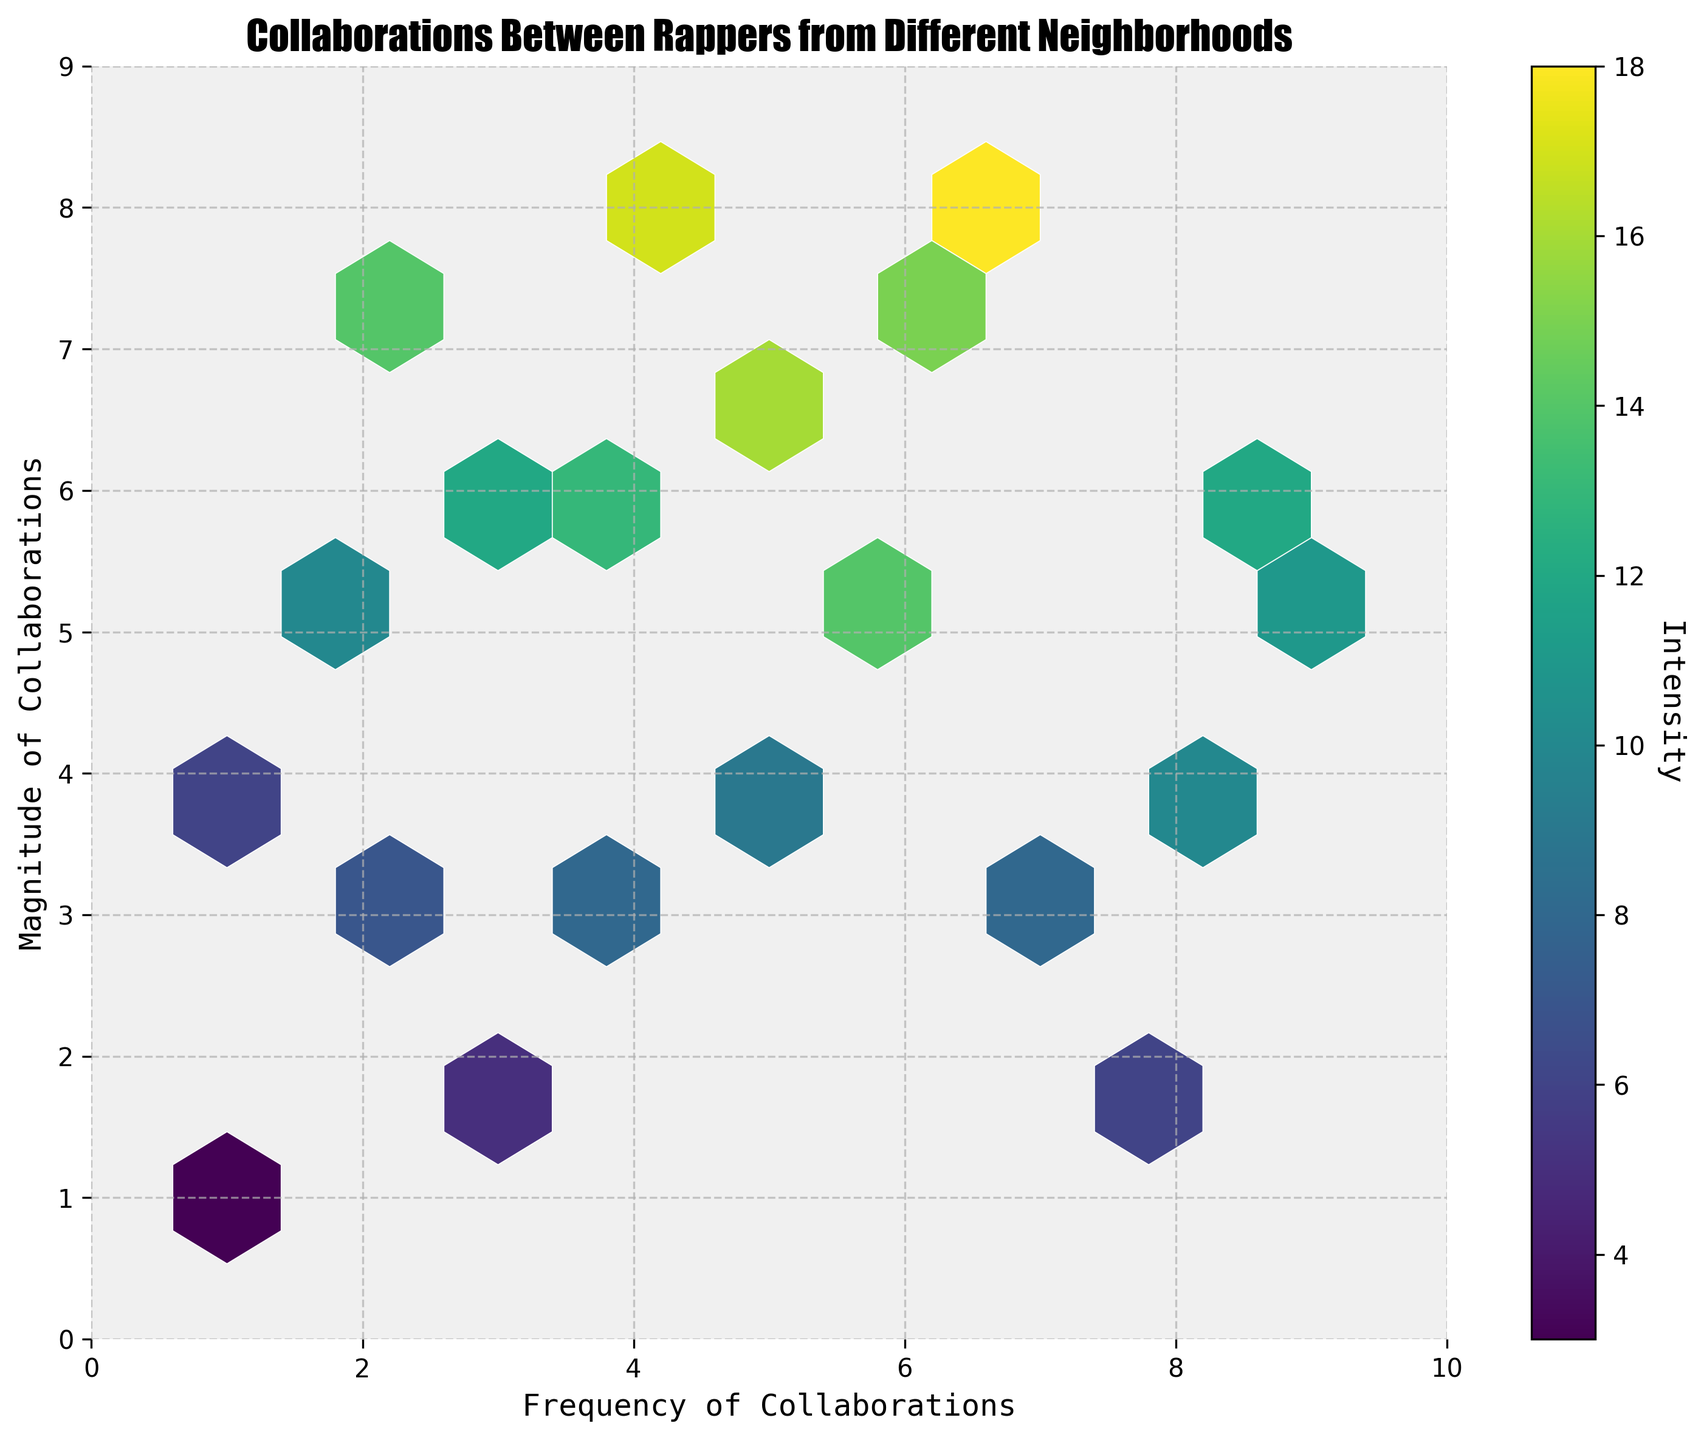What is the title of the figure? The title is usually placed at the top of the figure and is clearly visible to summarize what the plot is about.
Answer: Collaborations Between Rappers from Different Neighborhoods What are the labels for the x and y axes? The labels for the axes are usually located along the axes themselves and describe what each axis represents.
Answer: Frequency of Collaborations (x-axis), Magnitude of Collaborations (y-axis) What does the color bar to the right of the plot represent? The color bar next to the plot indicates the intensity of the collaborations. The label on the color bar explains what it represents.
Answer: Intensity How many hexagons with the highest intensity are visible on the plot? To answer this, we need to look for the hexagons with the darkest color, as the intensity is depicted by color shading.
Answer: 1 Where in the plot is the highest frequency and magnitude of collaborations located? The plot shows frequency (x-axis) and magnitude (y-axis); the highest values for both would likely be represented by the darkest hexagon at the upper range of both axes.
Answer: Around (7, 8) Which part of the plot shows the lowest collaboration intensity? This can be determined by finding the hexagons with the lightest color, indicating the lowest intensities.
Answer: Around (1, 1) What is the range of the color bar representing intensity? The range can be determined by the minimum and maximum values displayed next to the color bar.
Answer: 3 to 18 Is there a discernible pattern of collaboration frequency and magnitude from the hexbin plot? To answer this, we must analyze the distribution and density of the hexagons on the plot.
Answer: Yes, there appears to be a trend where higher frequencies often lead to higher magnitudes of collaboration Do collaborations with a frequency of 4 have more variability in magnitude compared to a frequency of 8? To answer this, compare the hexagons positioned vertically at x=4 and x=8 in terms of their distribution on the y-axis and intensity.
Answer: Yes, x=4 has a wider range in y compared to x=8 What neighborhood frequency has the highest collaboration magnitude on average? To determine this, find which x-value range has hexagons with relatively higher intensities on average, focusing on the y-value.
Answer: Around 7 